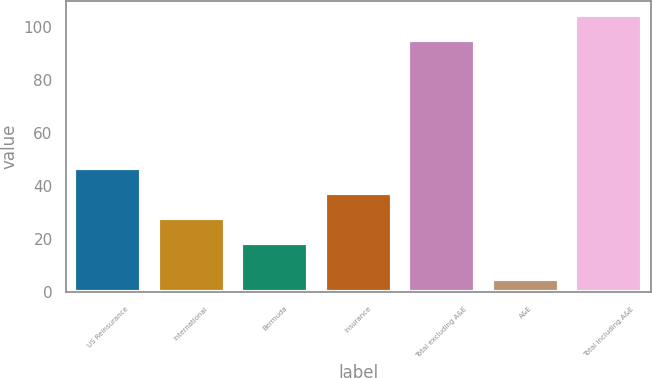<chart> <loc_0><loc_0><loc_500><loc_500><bar_chart><fcel>US Reinsurance<fcel>International<fcel>Bermuda<fcel>Insurance<fcel>Total excluding A&E<fcel>A&E<fcel>Total including A&E<nl><fcel>47.03<fcel>28.01<fcel>18.5<fcel>37.52<fcel>95.1<fcel>4.9<fcel>104.61<nl></chart> 